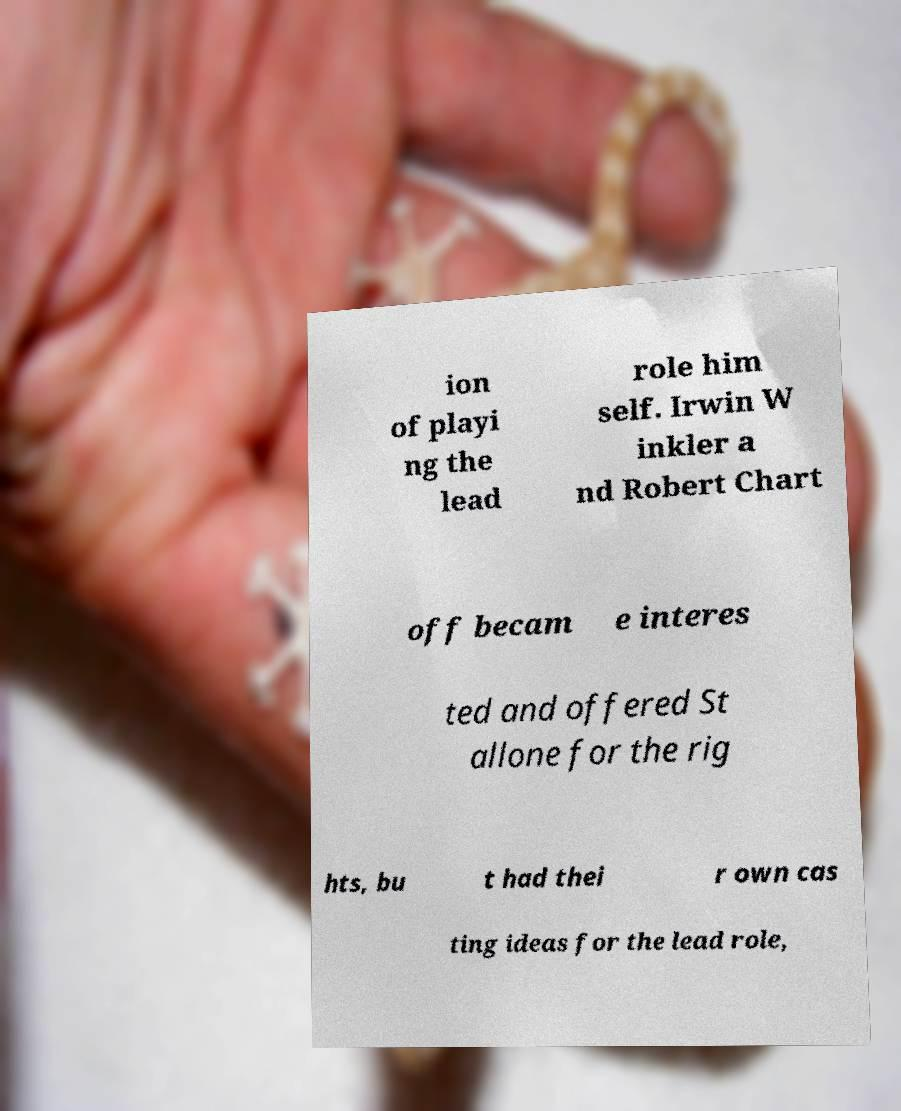I need the written content from this picture converted into text. Can you do that? ion of playi ng the lead role him self. Irwin W inkler a nd Robert Chart off becam e interes ted and offered St allone for the rig hts, bu t had thei r own cas ting ideas for the lead role, 